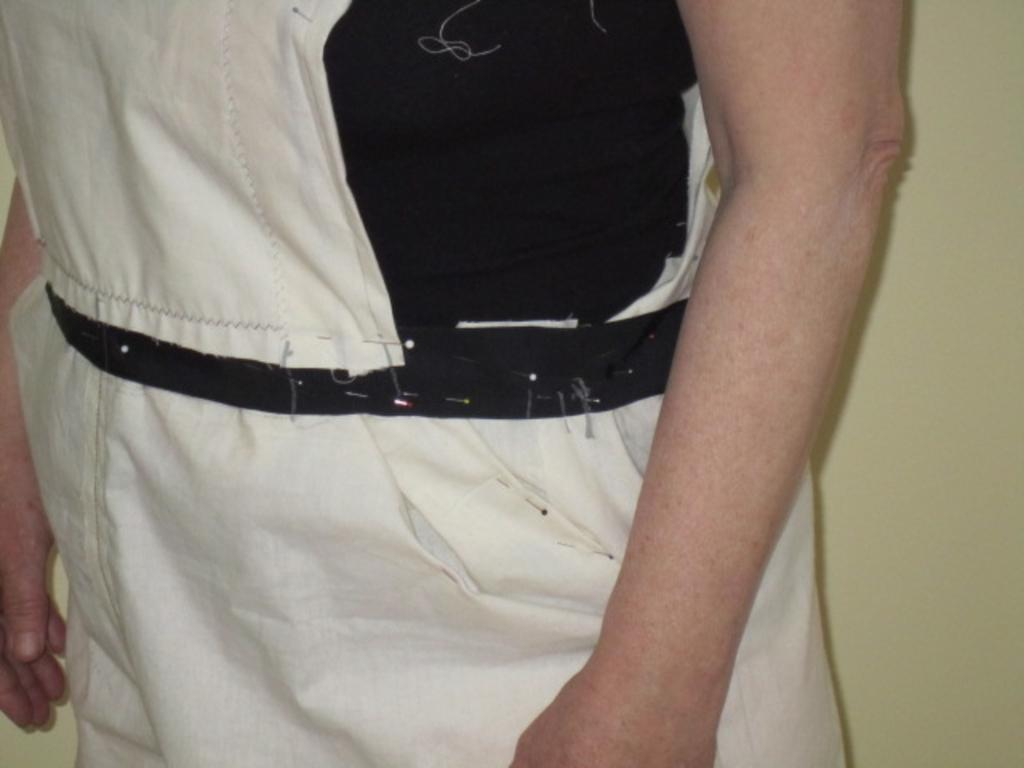What body parts are visible in the image? There are human hands in the image. What color scheme is used for the hands and the dress in the image? The hands and the dress are in black and white color. What type of clothing is present in the image? There is a dress in the image. How many bikes are locked up in the jail in the image? There are no bikes or jails present in the image; it features human hands and a dress in black and white color. 